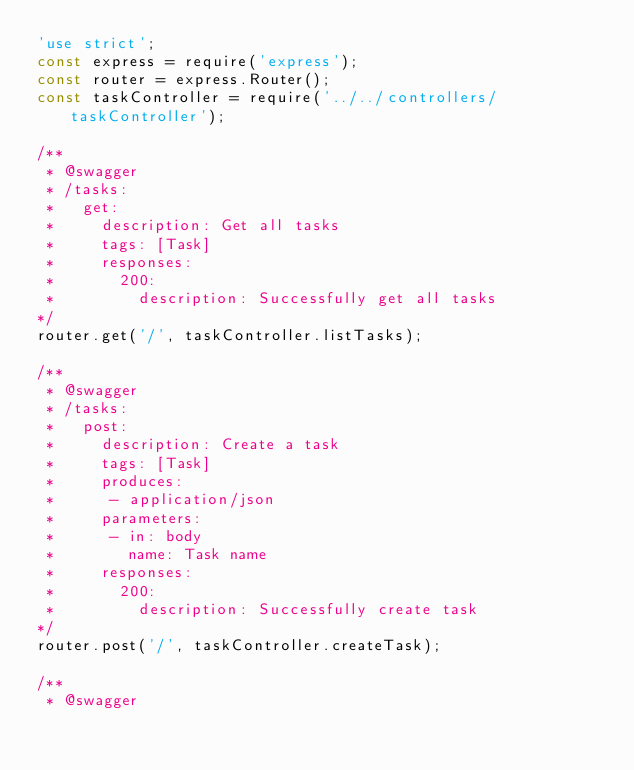<code> <loc_0><loc_0><loc_500><loc_500><_JavaScript_>'use strict';
const express = require('express');
const router = express.Router();
const taskController = require('../../controllers/taskController');

/**
 * @swagger
 * /tasks:
 *   get:
 *     description: Get all tasks
 *     tags: [Task]
 *     responses:
 *       200:
 *         description: Successfully get all tasks
*/
router.get('/', taskController.listTasks);

/**
 * @swagger
 * /tasks:
 *   post:
 *     description: Create a task
 *     tags: [Task]
 *     produces:      
 *      - application/json
 *     parameters:
 *      - in: body
 *        name: Task name
 *     responses:
 *       200:
 *         description: Successfully create task
*/
router.post('/', taskController.createTask);

/**
 * @swagger</code> 